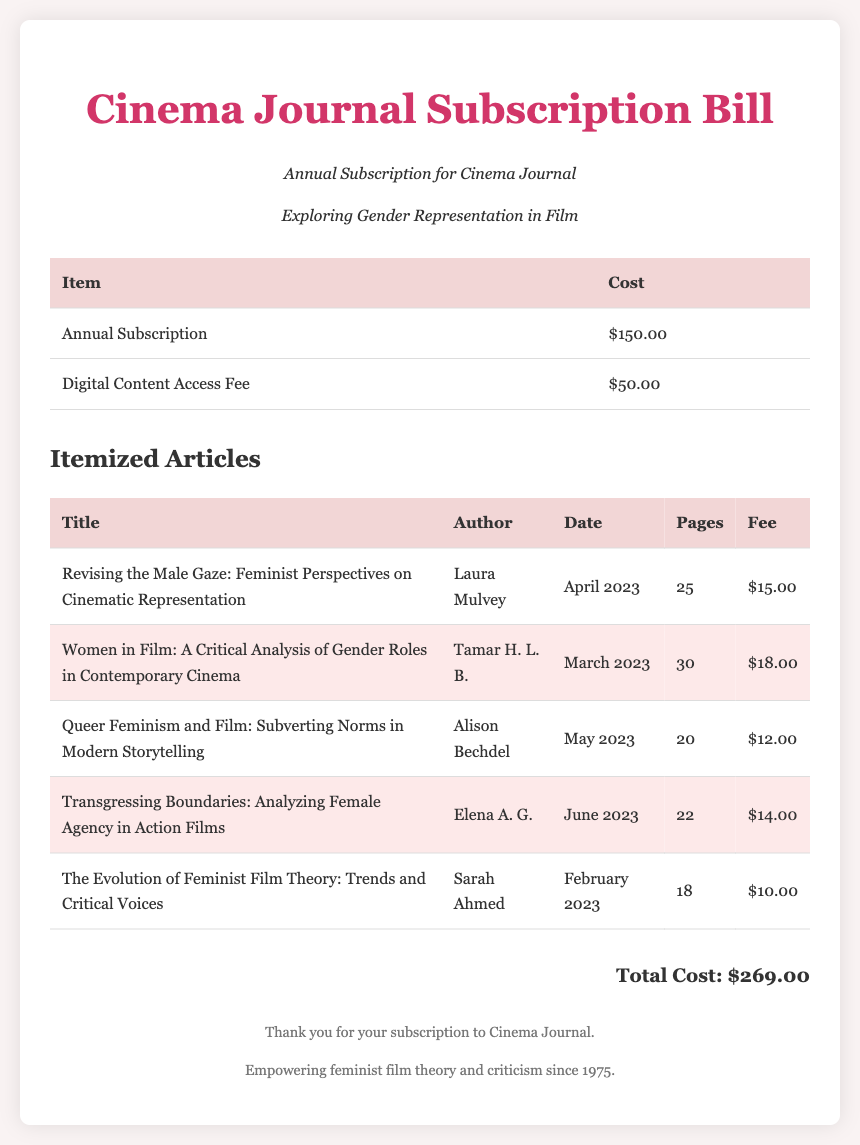What is the title of the journal? The title of the journal is prominently displayed at the top of the document.
Answer: Cinema Journal Who authored "Women in Film: A Critical Analysis of Gender Roles in Contemporary Cinema"? The author's name is found in the specific row for that article in the itemized articles table.
Answer: Tamar H. L. B What is the cost of the Annual Subscription? The cost is listed next to the "Annual Subscription" item in the main table of the document.
Answer: $150.00 How many pages is the article "Transgressing Boundaries: Analyzing Female Agency in Action Films"? The number of pages is specified in the column corresponding to that article in the itemized articles table.
Answer: 22 What is the total cost of the subscription bill? The total cost is calculated from all items listed and is displayed at the bottom of the document.
Answer: $269.00 Which article discusses Queer Feminism? The article title is easily identifiable under its respective section within the itemized articles.
Answer: Queer Feminism and Film: Subverting Norms in Modern Storytelling What is the digital content access fee? The fee is explicitly mentioned in the main cost table of the subscription bill.
Answer: $50.00 How many articles were highlighted in the document? The number of highlighted articles can be determined by counting the rows marked with the highlight class.
Answer: 3 